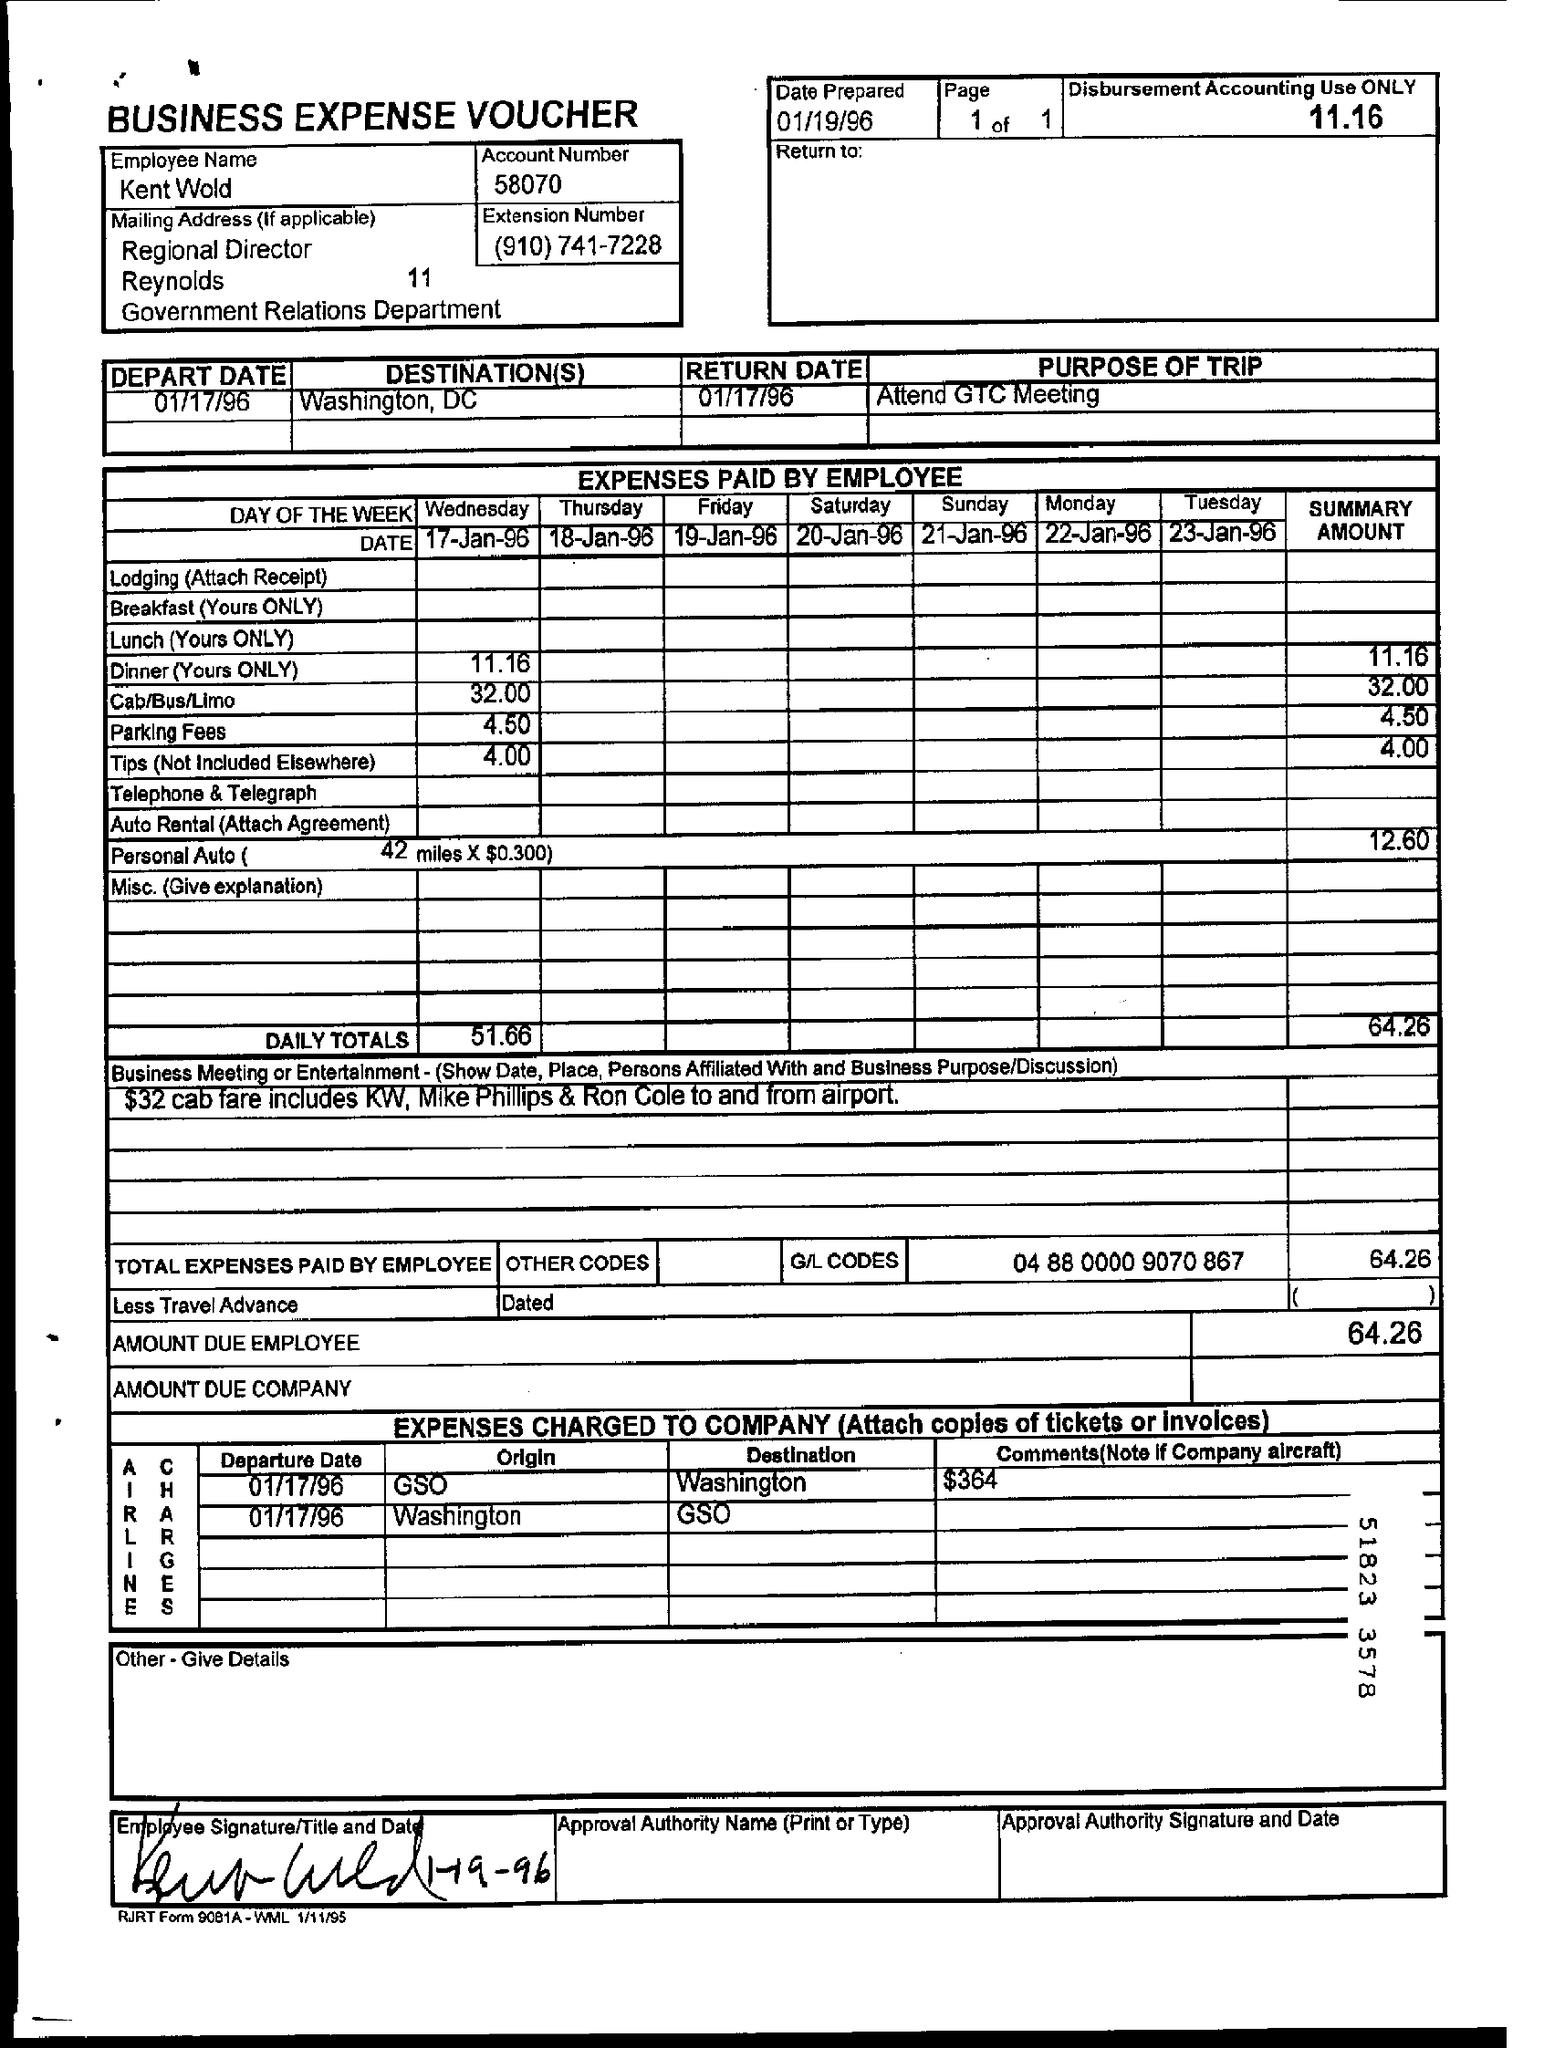What type of documentation is this?
Give a very brief answer. BUSINESS EXPENSE VOUCHER. What is the employee name?
Give a very brief answer. Kent Wold. What is the Account Number?
Offer a terse response. 58070. What is the purpose of trip?
Provide a succinct answer. Attend GTC Meeting. What is the date prepared?
Provide a short and direct response. 01/19/96. 